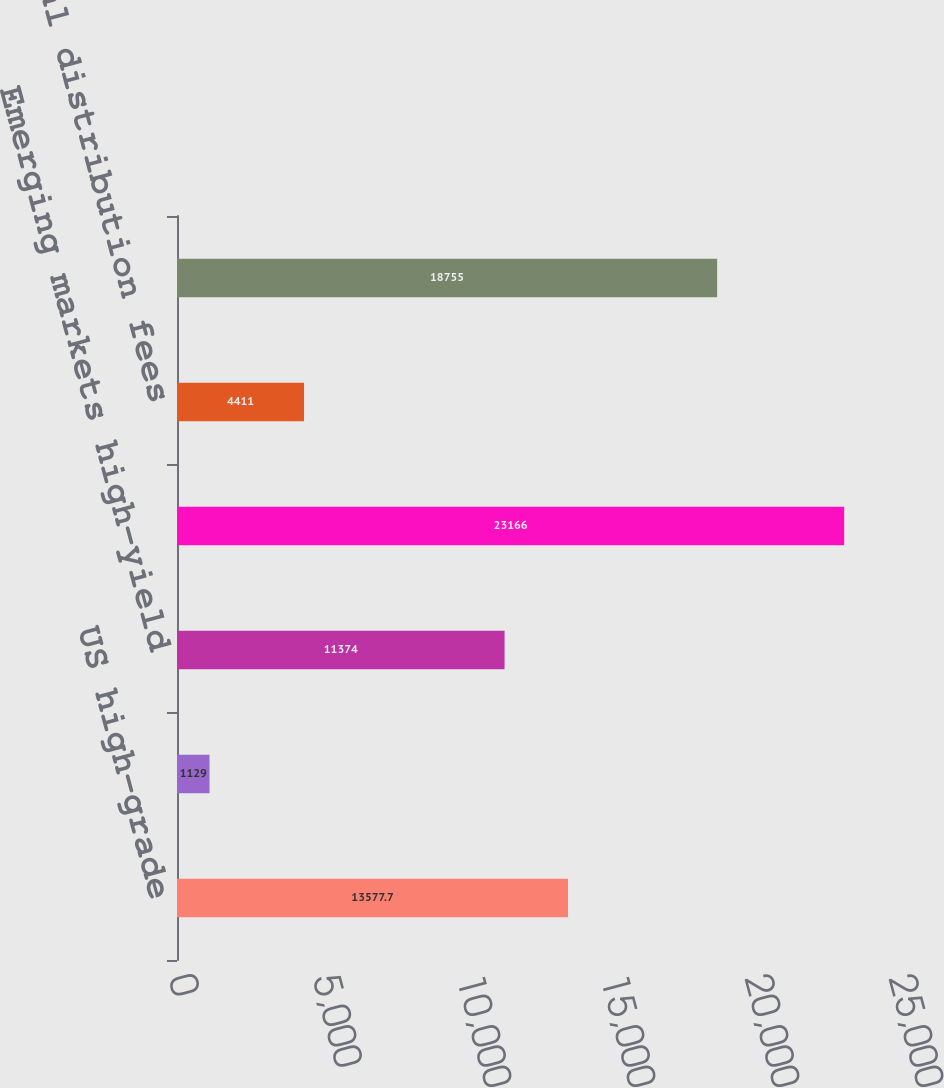Convert chart to OTSL. <chart><loc_0><loc_0><loc_500><loc_500><bar_chart><fcel>US high-grade<fcel>Eurobond<fcel>Emerging markets high-yield<fcel>Total variable transaction<fcel>Total distribution fees<fcel>Total commissions<nl><fcel>13577.7<fcel>1129<fcel>11374<fcel>23166<fcel>4411<fcel>18755<nl></chart> 